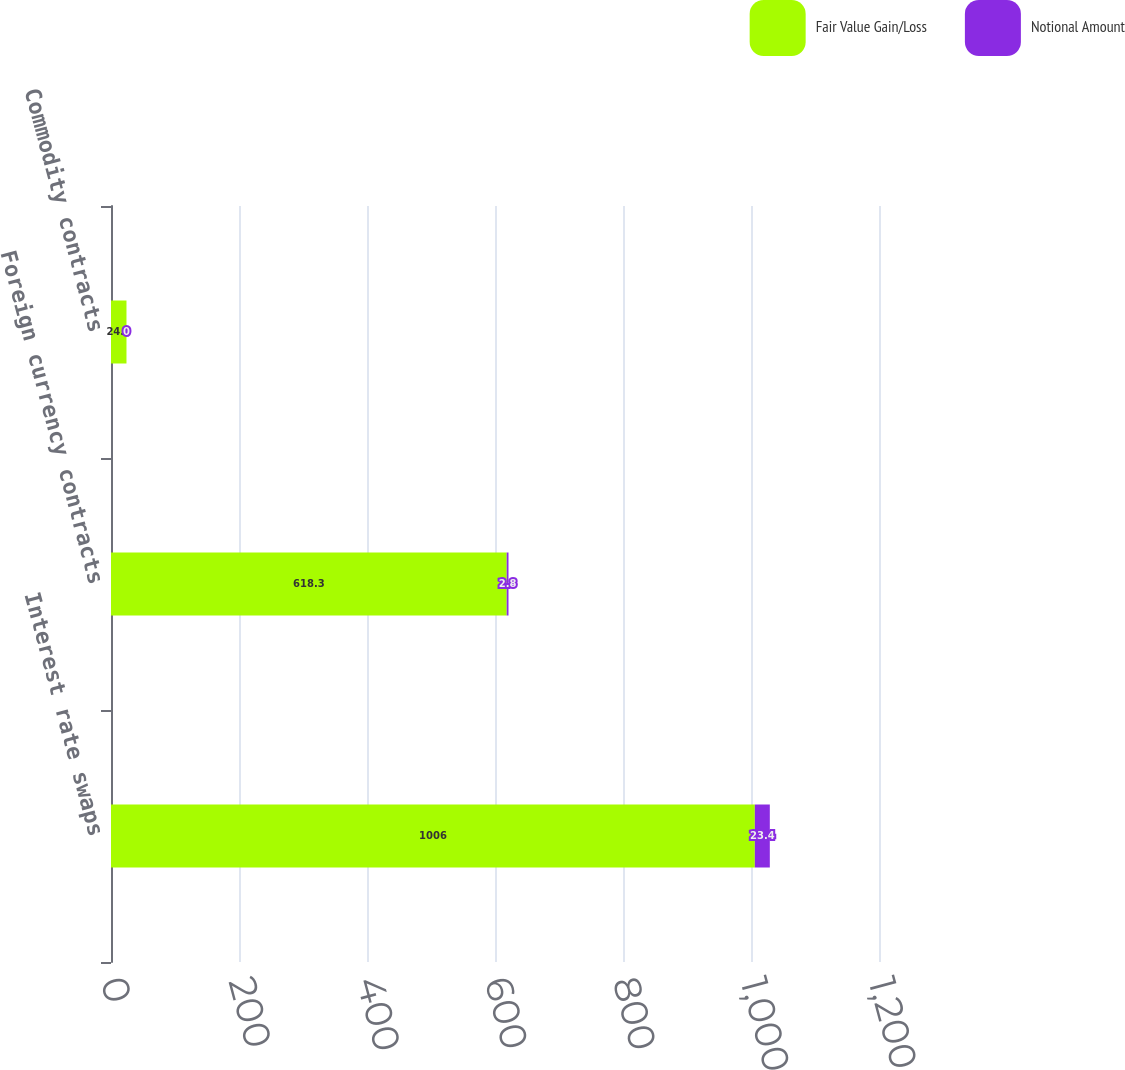<chart> <loc_0><loc_0><loc_500><loc_500><stacked_bar_chart><ecel><fcel>Interest rate swaps<fcel>Foreign currency contracts<fcel>Commodity contracts<nl><fcel>Fair Value Gain/Loss<fcel>1006<fcel>618.3<fcel>24.2<nl><fcel>Notional Amount<fcel>23.4<fcel>2.8<fcel>0<nl></chart> 